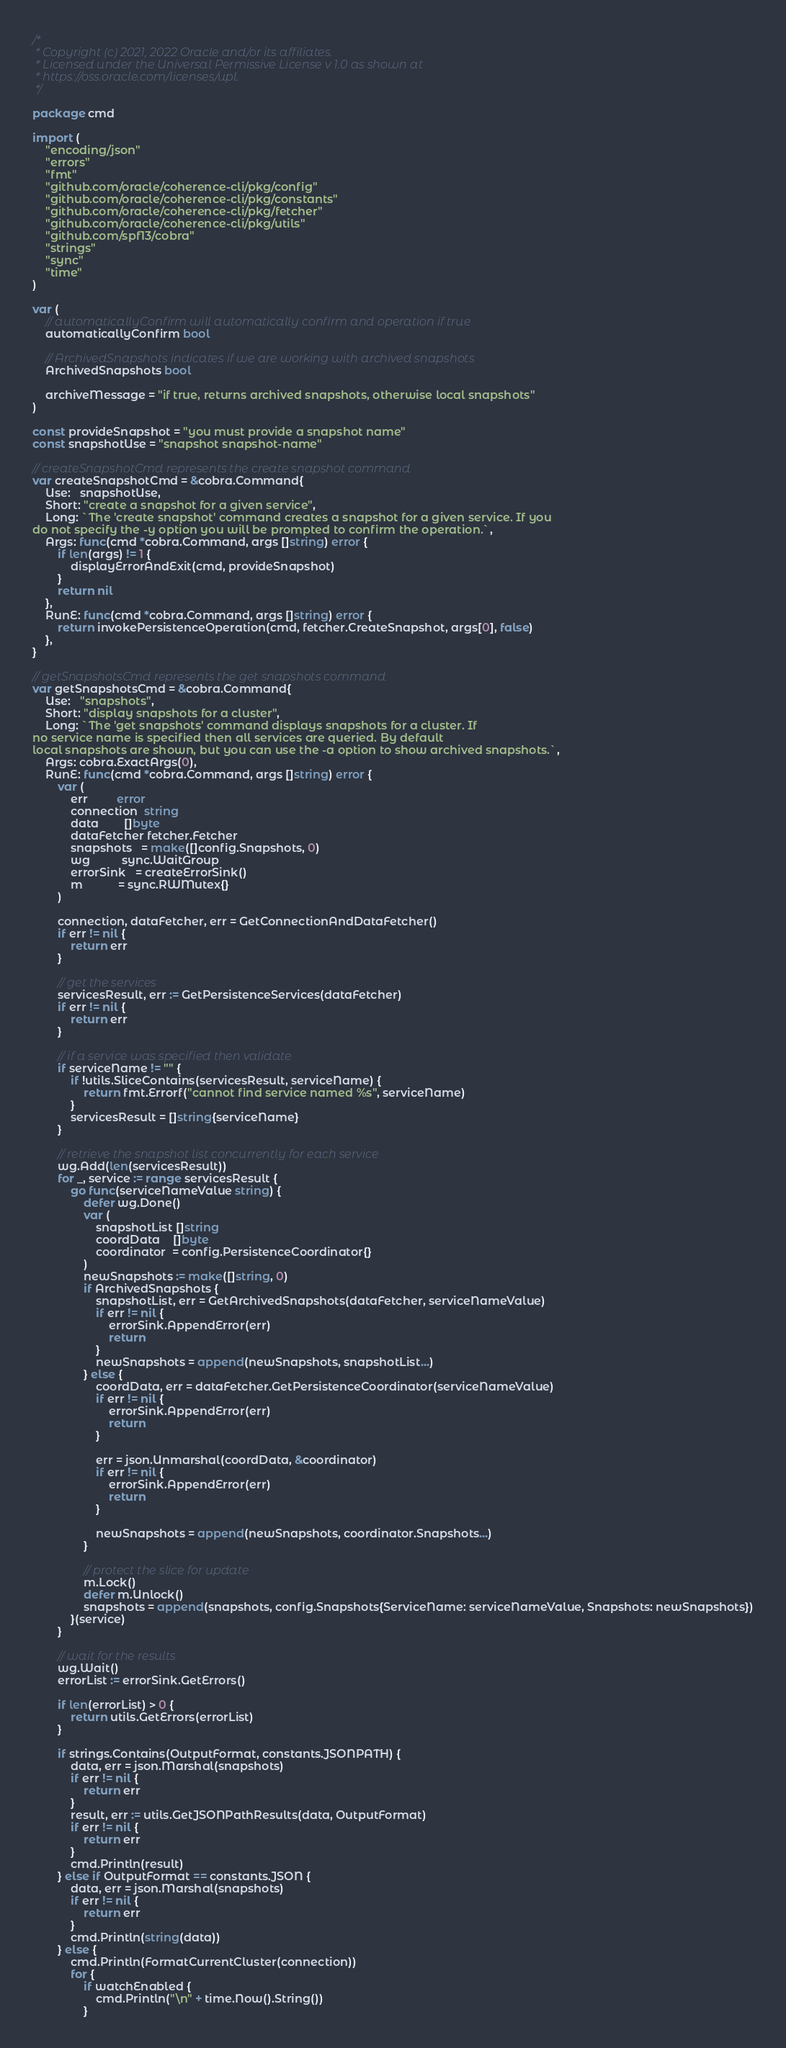<code> <loc_0><loc_0><loc_500><loc_500><_Go_>/*
 * Copyright (c) 2021, 2022 Oracle and/or its affiliates.
 * Licensed under the Universal Permissive License v 1.0 as shown at
 * https://oss.oracle.com/licenses/upl.
 */

package cmd

import (
	"encoding/json"
	"errors"
	"fmt"
	"github.com/oracle/coherence-cli/pkg/config"
	"github.com/oracle/coherence-cli/pkg/constants"
	"github.com/oracle/coherence-cli/pkg/fetcher"
	"github.com/oracle/coherence-cli/pkg/utils"
	"github.com/spf13/cobra"
	"strings"
	"sync"
	"time"
)

var (
	// automaticallyConfirm will automatically confirm and operation if true
	automaticallyConfirm bool

	// ArchivedSnapshots indicates if we are working with archived snapshots
	ArchivedSnapshots bool

	archiveMessage = "if true, returns archived snapshots, otherwise local snapshots"
)

const provideSnapshot = "you must provide a snapshot name"
const snapshotUse = "snapshot snapshot-name"

// createSnapshotCmd represents the create snapshot command
var createSnapshotCmd = &cobra.Command{
	Use:   snapshotUse,
	Short: "create a snapshot for a given service",
	Long: `The 'create snapshot' command creates a snapshot for a given service. If you 
do not specify the -y option you will be prompted to confirm the operation.`,
	Args: func(cmd *cobra.Command, args []string) error {
		if len(args) != 1 {
			displayErrorAndExit(cmd, provideSnapshot)
		}
		return nil
	},
	RunE: func(cmd *cobra.Command, args []string) error {
		return invokePersistenceOperation(cmd, fetcher.CreateSnapshot, args[0], false)
	},
}

// getSnapshotsCmd represents the get snapshots command
var getSnapshotsCmd = &cobra.Command{
	Use:   "snapshots",
	Short: "display snapshots for a cluster",
	Long: `The 'get snapshots' command displays snapshots for a cluster. If 
no service name is specified then all services are queried. By default 
local snapshots are shown, but you can use the -a option to show archived snapshots.`,
	Args: cobra.ExactArgs(0),
	RunE: func(cmd *cobra.Command, args []string) error {
		var (
			err         error
			connection  string
			data        []byte
			dataFetcher fetcher.Fetcher
			snapshots   = make([]config.Snapshots, 0)
			wg          sync.WaitGroup
			errorSink   = createErrorSink()
			m           = sync.RWMutex{}
		)

		connection, dataFetcher, err = GetConnectionAndDataFetcher()
		if err != nil {
			return err
		}

		// get the services
		servicesResult, err := GetPersistenceServices(dataFetcher)
		if err != nil {
			return err
		}

		// if a service was specified then validate
		if serviceName != "" {
			if !utils.SliceContains(servicesResult, serviceName) {
				return fmt.Errorf("cannot find service named %s", serviceName)
			}
			servicesResult = []string{serviceName}
		}

		// retrieve the snapshot list concurrently for each service
		wg.Add(len(servicesResult))
		for _, service := range servicesResult {
			go func(serviceNameValue string) {
				defer wg.Done()
				var (
					snapshotList []string
					coordData    []byte
					coordinator  = config.PersistenceCoordinator{}
				)
				newSnapshots := make([]string, 0)
				if ArchivedSnapshots {
					snapshotList, err = GetArchivedSnapshots(dataFetcher, serviceNameValue)
					if err != nil {
						errorSink.AppendError(err)
						return
					}
					newSnapshots = append(newSnapshots, snapshotList...)
				} else {
					coordData, err = dataFetcher.GetPersistenceCoordinator(serviceNameValue)
					if err != nil {
						errorSink.AppendError(err)
						return
					}

					err = json.Unmarshal(coordData, &coordinator)
					if err != nil {
						errorSink.AppendError(err)
						return
					}

					newSnapshots = append(newSnapshots, coordinator.Snapshots...)
				}

				// protect the slice for update
				m.Lock()
				defer m.Unlock()
				snapshots = append(snapshots, config.Snapshots{ServiceName: serviceNameValue, Snapshots: newSnapshots})
			}(service)
		}

		// wait for the results
		wg.Wait()
		errorList := errorSink.GetErrors()

		if len(errorList) > 0 {
			return utils.GetErrors(errorList)
		}

		if strings.Contains(OutputFormat, constants.JSONPATH) {
			data, err = json.Marshal(snapshots)
			if err != nil {
				return err
			}
			result, err := utils.GetJSONPathResults(data, OutputFormat)
			if err != nil {
				return err
			}
			cmd.Println(result)
		} else if OutputFormat == constants.JSON {
			data, err = json.Marshal(snapshots)
			if err != nil {
				return err
			}
			cmd.Println(string(data))
		} else {
			cmd.Println(FormatCurrentCluster(connection))
			for {
				if watchEnabled {
					cmd.Println("\n" + time.Now().String())
				}
</code> 